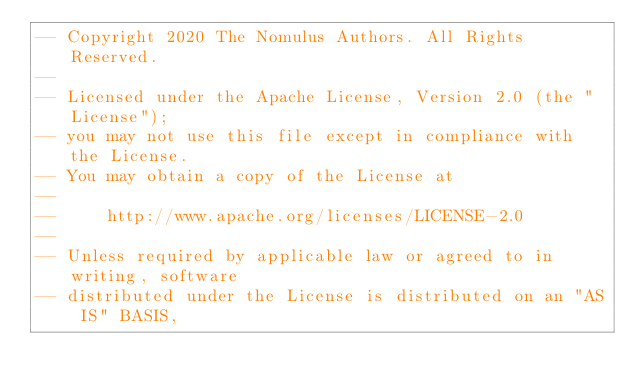Convert code to text. <code><loc_0><loc_0><loc_500><loc_500><_SQL_>-- Copyright 2020 The Nomulus Authors. All Rights Reserved.
--
-- Licensed under the Apache License, Version 2.0 (the "License");
-- you may not use this file except in compliance with the License.
-- You may obtain a copy of the License at
--
--     http://www.apache.org/licenses/LICENSE-2.0
--
-- Unless required by applicable law or agreed to in writing, software
-- distributed under the License is distributed on an "AS IS" BASIS,</code> 